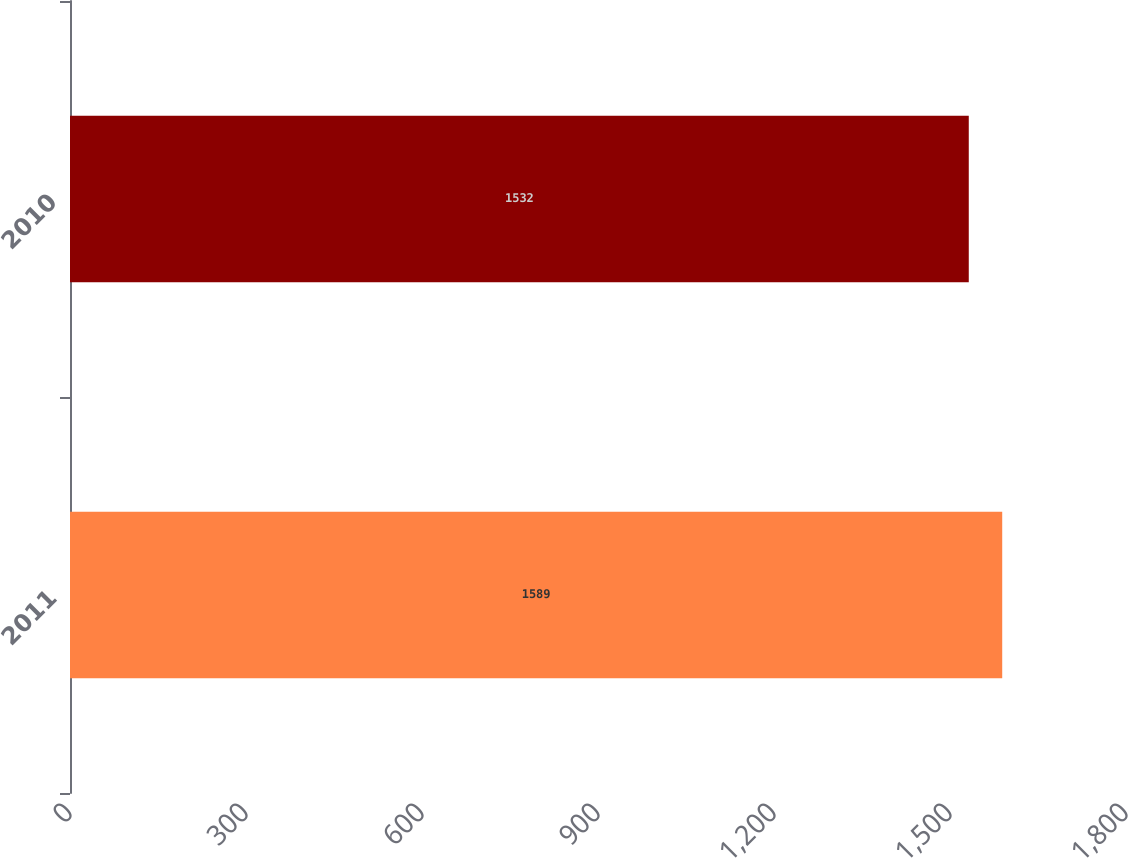<chart> <loc_0><loc_0><loc_500><loc_500><bar_chart><fcel>2011<fcel>2010<nl><fcel>1589<fcel>1532<nl></chart> 